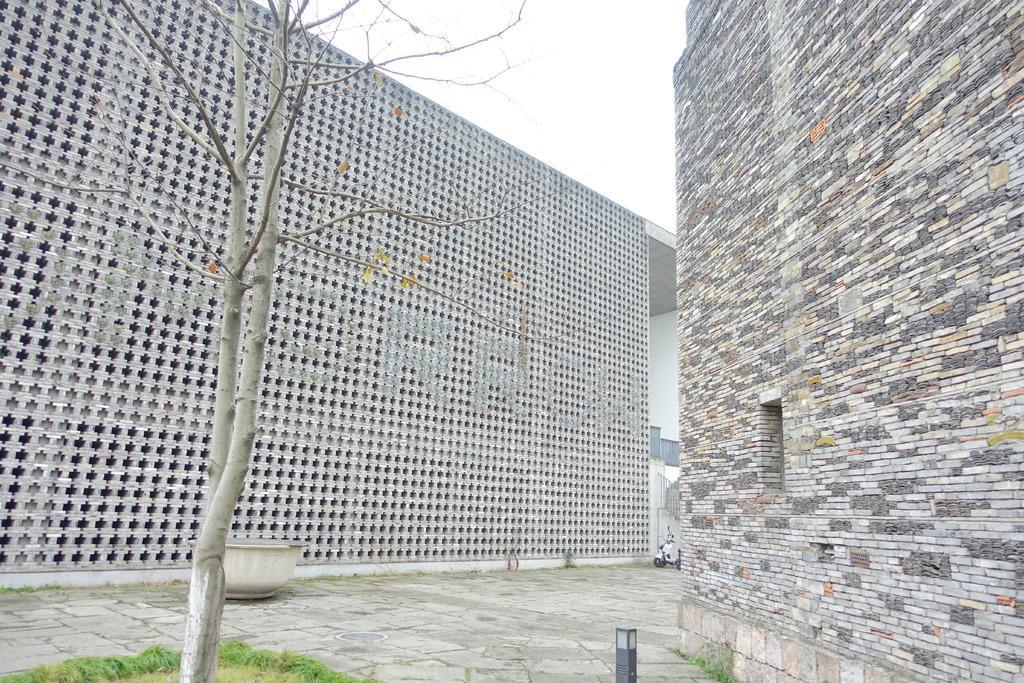How would you summarize this image in a sentence or two? In the image we can see there are buildings and there is a tree on the ground. There is grass on the ground and there is a bike parked on the ground. There is a clear sky. 